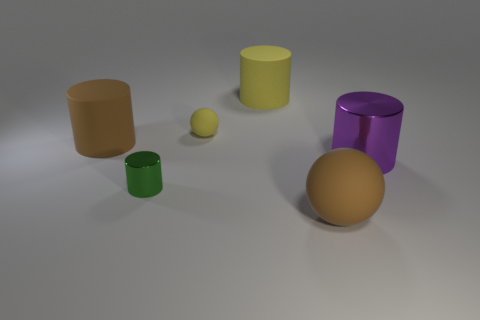What number of purple objects are there?
Offer a very short reply. 1. Are there fewer yellow matte cylinders than gray cylinders?
Give a very brief answer. No. There is a purple cylinder that is the same size as the yellow matte cylinder; what material is it?
Keep it short and to the point. Metal. What number of things are brown matte spheres or yellow spheres?
Ensure brevity in your answer.  2. How many things are on the left side of the purple cylinder and in front of the yellow matte cylinder?
Provide a short and direct response. 4. Is the number of big brown matte spheres to the left of the green cylinder less than the number of big cylinders?
Give a very brief answer. Yes. What shape is the purple shiny object that is the same size as the brown cylinder?
Ensure brevity in your answer.  Cylinder. What number of other things are there of the same color as the tiny matte sphere?
Provide a short and direct response. 1. Is the green cylinder the same size as the yellow rubber sphere?
Keep it short and to the point. Yes. How many objects are either small yellow objects or metallic cylinders to the left of the small yellow object?
Offer a very short reply. 2. 